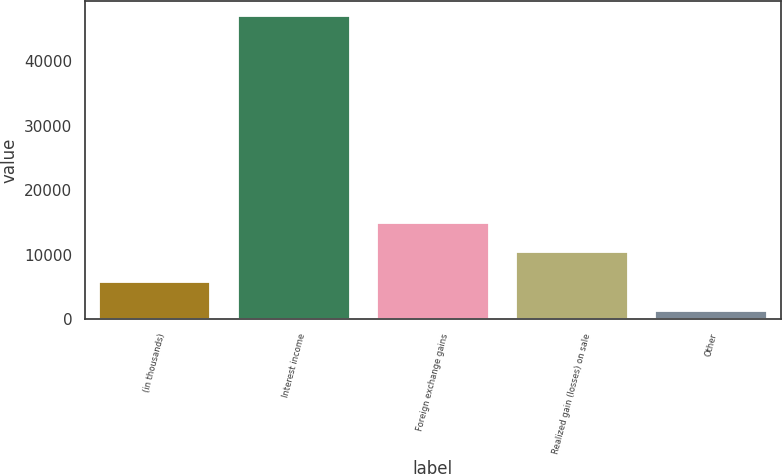Convert chart. <chart><loc_0><loc_0><loc_500><loc_500><bar_chart><fcel>(in thousands)<fcel>Interest income<fcel>Foreign exchange gains<fcel>Realized gain (losses) on sale<fcel>Other<nl><fcel>5812.4<fcel>47009<fcel>14967.2<fcel>10389.8<fcel>1235<nl></chart> 